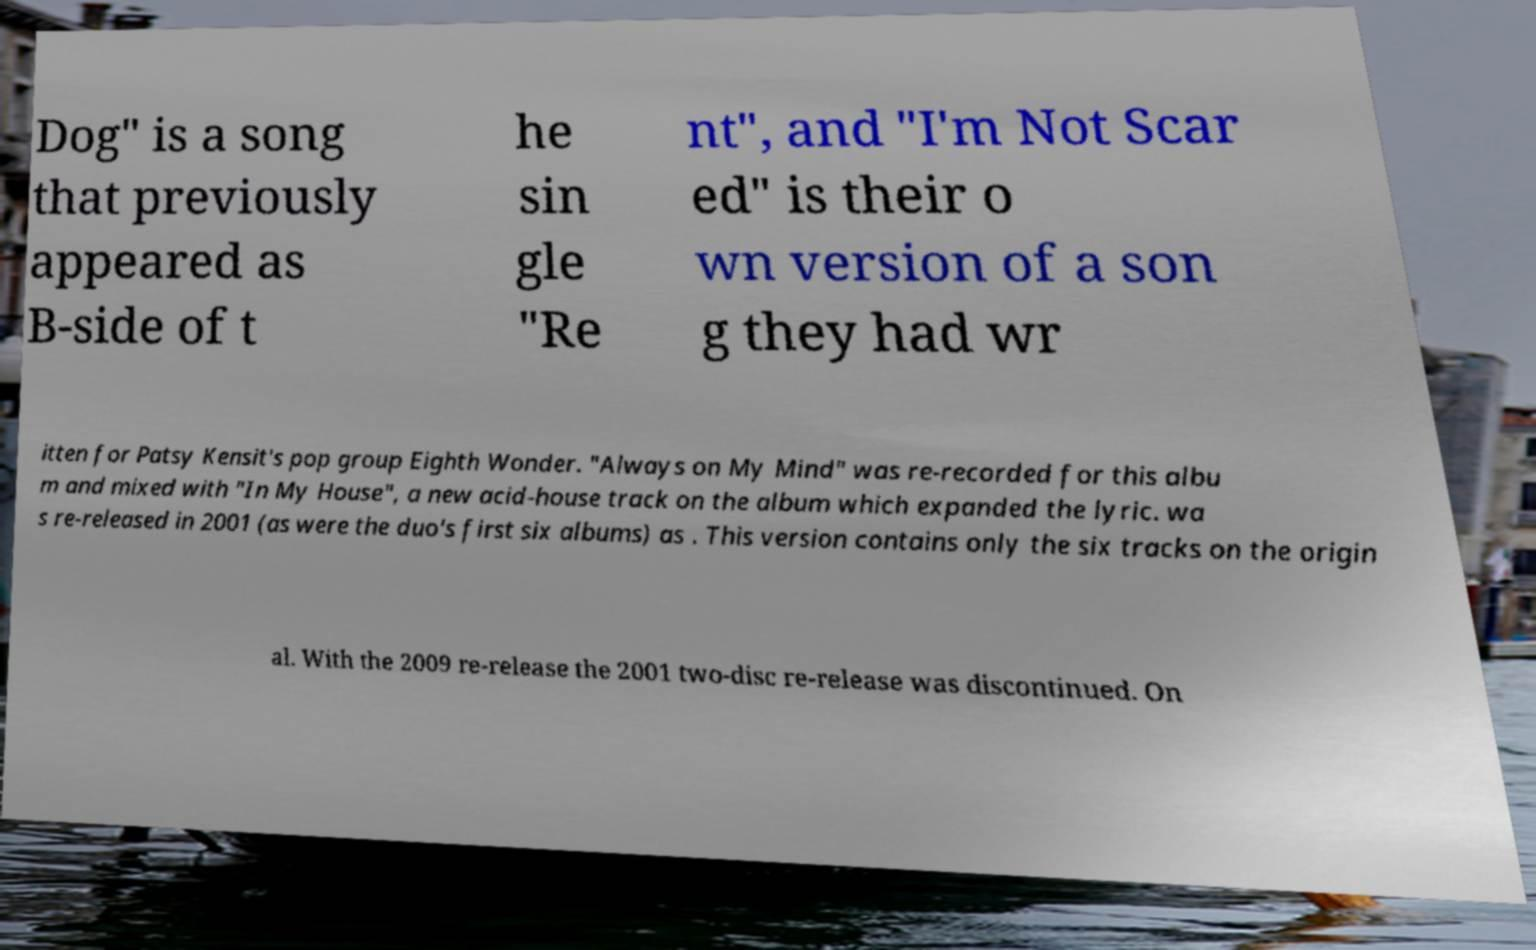For documentation purposes, I need the text within this image transcribed. Could you provide that? Dog" is a song that previously appeared as B-side of t he sin gle "Re nt", and "I'm Not Scar ed" is their o wn version of a son g they had wr itten for Patsy Kensit's pop group Eighth Wonder. "Always on My Mind" was re-recorded for this albu m and mixed with "In My House", a new acid-house track on the album which expanded the lyric. wa s re-released in 2001 (as were the duo's first six albums) as . This version contains only the six tracks on the origin al. With the 2009 re-release the 2001 two-disc re-release was discontinued. On 